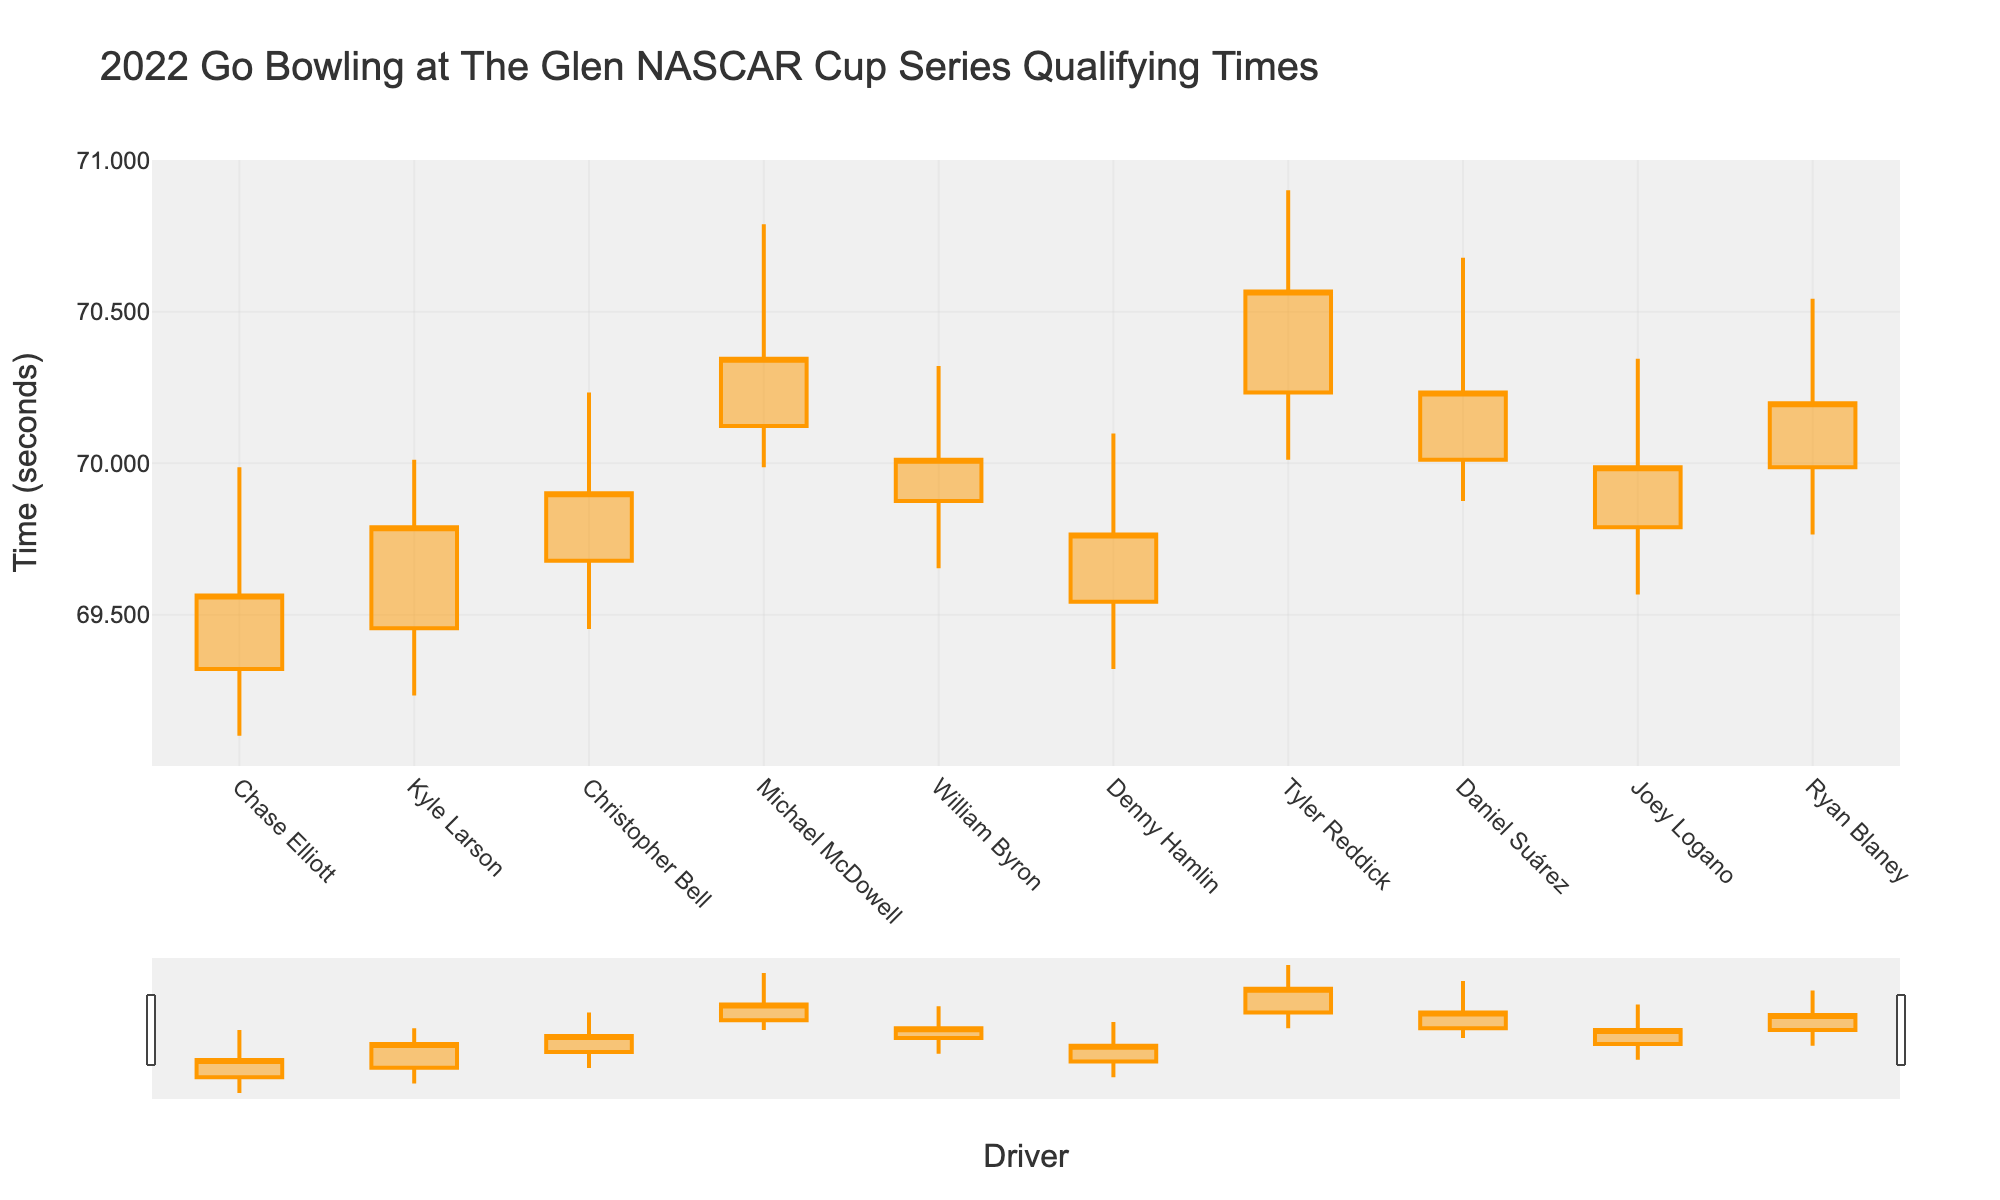Who has the fastest low qualifying time? The driver with the fastest low qualifying time is the one with the smallest "Low" value. According to the data, Chase Elliott has the fastest low time of 69.101 seconds.
Answer: Chase Elliott Which driver’s closing time is higher, Kyle Larson or William Byron? To determine this, look at the "Close" times for both drivers. Kyle Larson's close time is 69.789 seconds, and William Byron's close time is 70.012 seconds. William Byron's close time is higher.
Answer: William Byron What is the average opening time for all drivers? Add up all the opening times and divide by the number of drivers. The total opening time sum is 69.321 + 69.456 + 69.678 + 70.123 + 69.876 + 69.543 + 70.234 + 70.012 + 69.789 + 69.987 = 697.019. There are 10 drivers, so the average is 697.019 / 10 = 69.702.
Answer: 69.7019 Which driver has the highest high time and what is that time? Identify the driver with the maximum "High" time. Tyler Reddick has the highest high time of 70.901 seconds.
Answer: Tyler Reddick How many drivers have a low time under 69.500 seconds? Count the number of drivers with a "Low" time less than 69.500 seconds. Chase Elliott (69.101), Kyle Larson (69.234), Christopher Bell (69.453), Denny Hamlin (69.321), and Joey Logano (69.567) fit this criterion. That's 4 drivers.
Answer: 4 What is the range of Michael McDowell’s times? The range is calculated by subtracting the "Low" time from the "High" time for Michael McDowell. His times range from 70.789 to 69.987 seconds. Therefore, the range is 70.789 - 69.987 = 0.802 seconds.
Answer: 0.802 Which driver has the smallest difference between their highest and lowest times? Calculate the difference between "High" and "Low" times for each driver and find the smallest. Chase Elliott: 69.987 - 69.101 = 0.886, Kyle Larson: 70.012 - 69.234 = 0.778, Christopher Bell: 70.234 - 69.453 = 0.781, Michael McDowell: 70.789 - 69.987 = 0.802, William Byron: 70.321 - 69.654 = 0.667, Denny Hamlin: 70.098 - 69.321 = 0.777, Tyler Reddick: 70.901 - 70.012 = 0.889, Daniel Suárez: 70.678 - 69.876 = 0.802, Joey Logano: 70.345 - 69.567 = 0.778, Ryan Blaney: 70.543 - 69.765 = 0.778. William Byron has the smallest difference of 0.667 seconds.
Answer: William Byron 